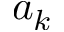Convert formula to latex. <formula><loc_0><loc_0><loc_500><loc_500>a _ { k }</formula> 